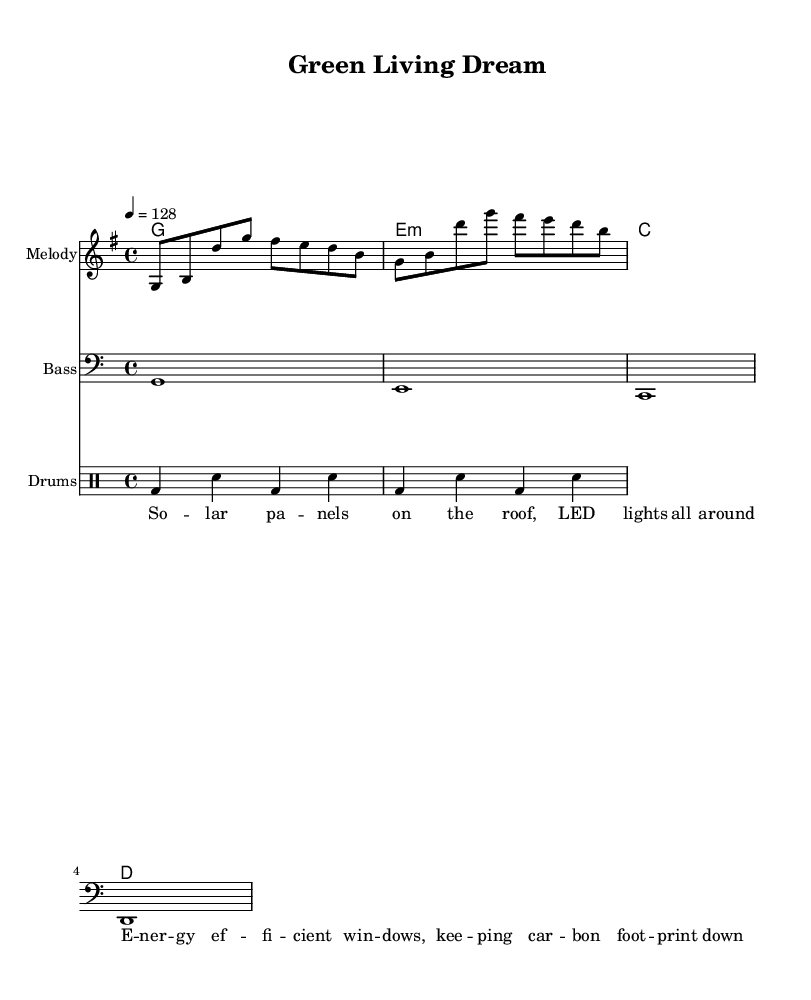What is the key signature of this music? The key signature is G major, indicated by the presence of one sharp (F#), which is shown at the beginning of the staff.
Answer: G major What is the time signature of this music? The time signature is 4/4, as indicated by the notation at the beginning of the piece which shows four beats per measure.
Answer: 4/4 What is the tempo marking for this piece? The tempo marking is 128, which indicates the speed of the piece in beats per minute as specified in the tempo indication.
Answer: 128 How many measures are in the melody? The melody consists of two measures based on the rhythmic grouping of the notes in the melody line, which is repeated.
Answer: 2 What type of drum patterns are utilized in this piece? The drum patterns include bass drum and snare hits in a consistent alternating rhythm, typical for electronic music genres.
Answer: Bass and snare What is the primary theme of the lyrics in this sheet music? The lyrics focus on environmentally friendly themes, specifically mentioning solar panels and energy-efficient windows, which supports a green technology topic.
Answer: Green technology What instruments are used in the score? The instruments included in the score are melody, bass, and drums, as indicated by their respective staff names.
Answer: Melody, bass, drums 